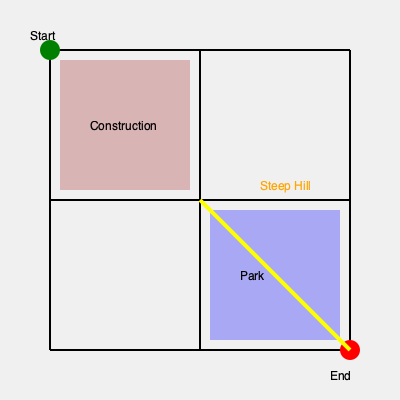Based on the neighborhood map, which route would be the safest and most suitable for seniors walking from the Start point to the End point? To determine the safest route for seniors, we need to consider several factors:

1. Avoid obstacles: The map shows a construction area in the top-left quadrant, which should be avoided for safety reasons.

2. Avoid steep inclines: There's a steep hill indicated by the yellow line from the center to the bottom-right corner, which could be challenging for seniors.

3. Utilize safe areas: The park in the bottom-center quadrant could provide a pleasant and safe walking environment.

4. Minimize distance: While not the most crucial factor, a shorter route is generally preferable if it meets other safety criteria.

Considering these factors, the safest route would be:
1. Start at the green point (top-left corner)
2. Move right along the top edge to the center-top intersection
3. Go down the center vertical line to the middle intersection
4. Turn right and enter the park area
5. Exit the park at the bottom-right corner to reach the end point (red circle)

This route avoids the construction area, doesn't include the steep hill, utilizes the safe park area, and maintains a relatively direct path to the destination.
Answer: Top edge → Center vertical → Through park 